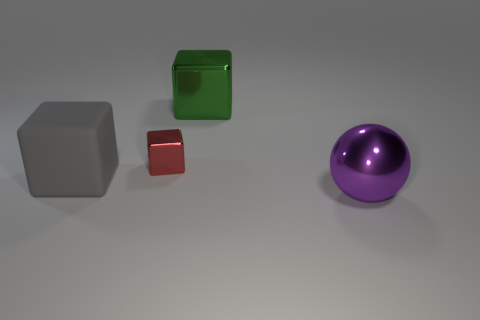Subtract all green blocks. How many blocks are left? 2 Subtract all cubes. How many objects are left? 1 Subtract all purple blocks. Subtract all green cylinders. How many blocks are left? 3 Add 3 red shiny blocks. How many objects exist? 7 Subtract all large green rubber cylinders. Subtract all large green blocks. How many objects are left? 3 Add 3 gray cubes. How many gray cubes are left? 4 Add 1 large purple objects. How many large purple objects exist? 2 Subtract 0 gray cylinders. How many objects are left? 4 